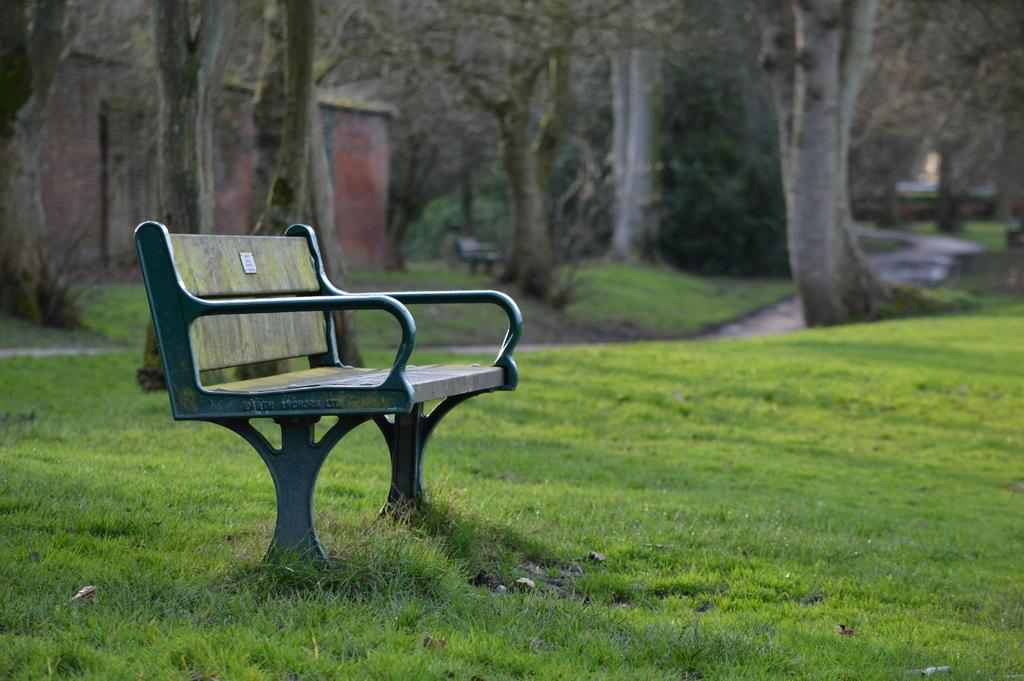What type of seating is visible in the image? There is a bench in the image. Where is the bench located? The bench is on grassy land. What can be seen in the background of the image? There are trees and a house in the background of the image. What type of lettuce is growing on the bench in the image? There is no lettuce present on the bench in the image. 